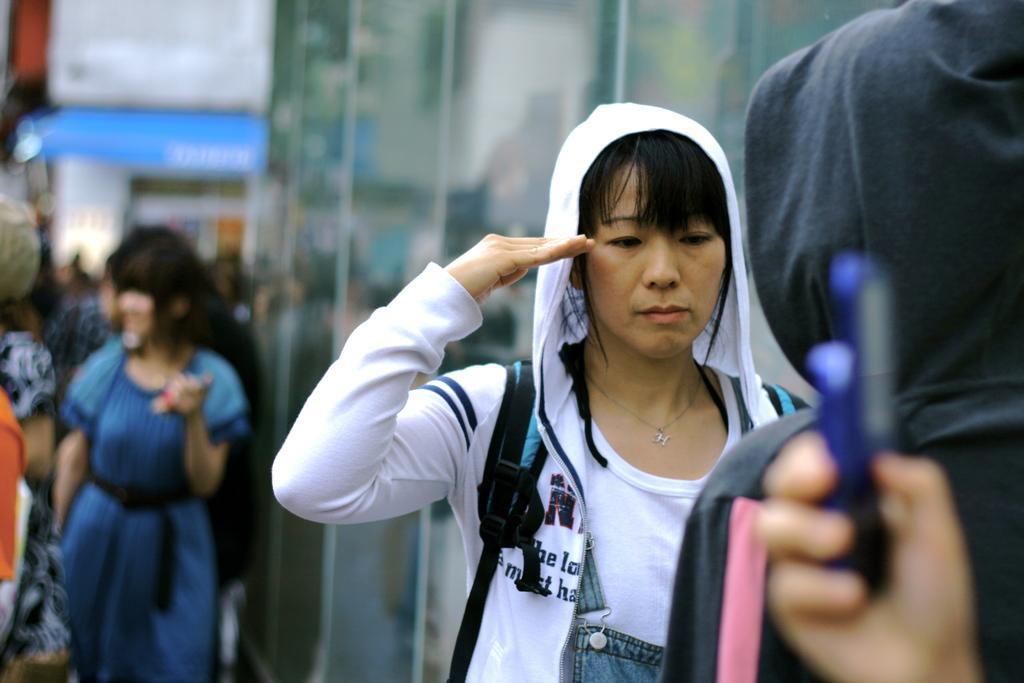Please provide a concise description of this image. In this image we can see many persons walking in the ground. In the background there is wall. 